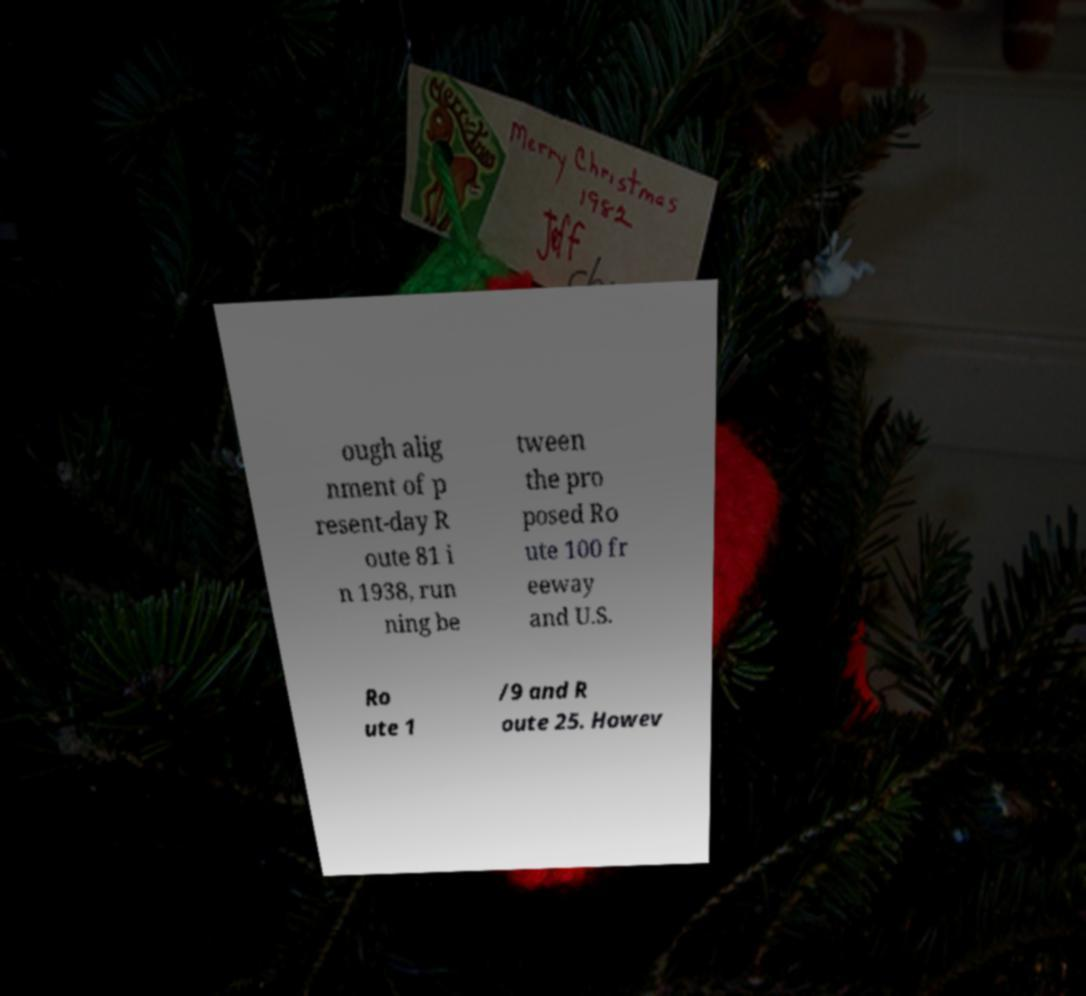Can you accurately transcribe the text from the provided image for me? ough alig nment of p resent-day R oute 81 i n 1938, run ning be tween the pro posed Ro ute 100 fr eeway and U.S. Ro ute 1 /9 and R oute 25. Howev 